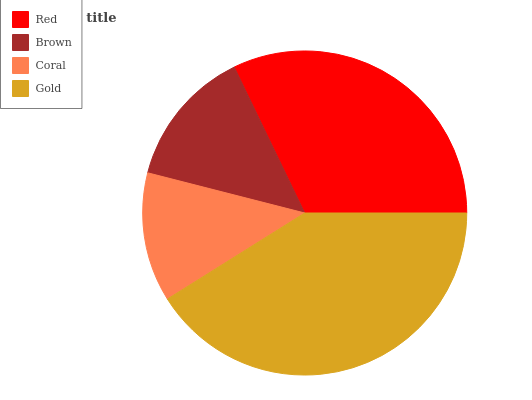Is Coral the minimum?
Answer yes or no. Yes. Is Gold the maximum?
Answer yes or no. Yes. Is Brown the minimum?
Answer yes or no. No. Is Brown the maximum?
Answer yes or no. No. Is Red greater than Brown?
Answer yes or no. Yes. Is Brown less than Red?
Answer yes or no. Yes. Is Brown greater than Red?
Answer yes or no. No. Is Red less than Brown?
Answer yes or no. No. Is Red the high median?
Answer yes or no. Yes. Is Brown the low median?
Answer yes or no. Yes. Is Gold the high median?
Answer yes or no. No. Is Red the low median?
Answer yes or no. No. 